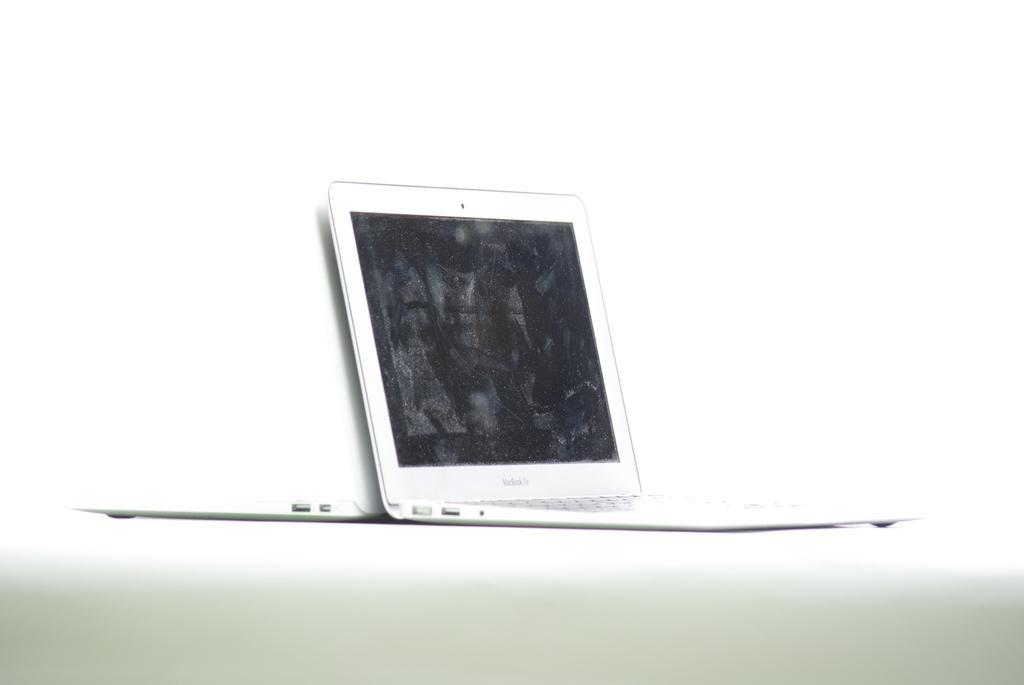Could you give a brief overview of what you see in this image? In this picture I can see a laptop placed on the white surface. 